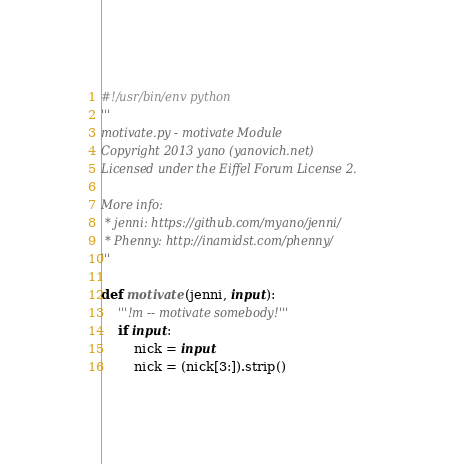Convert code to text. <code><loc_0><loc_0><loc_500><loc_500><_Python_>#!/usr/bin/env python
'''
motivate.py - motivate Module
Copyright 2013 yano (yanovich.net)
Licensed under the Eiffel Forum License 2.

More info:
 * jenni: https://github.com/myano/jenni/
 * Phenny: http://inamidst.com/phenny/
'''

def motivate(jenni, input):
    '''!m -- motivate somebody!'''
    if input:
        nick = input
        nick = (nick[3:]).strip()</code> 